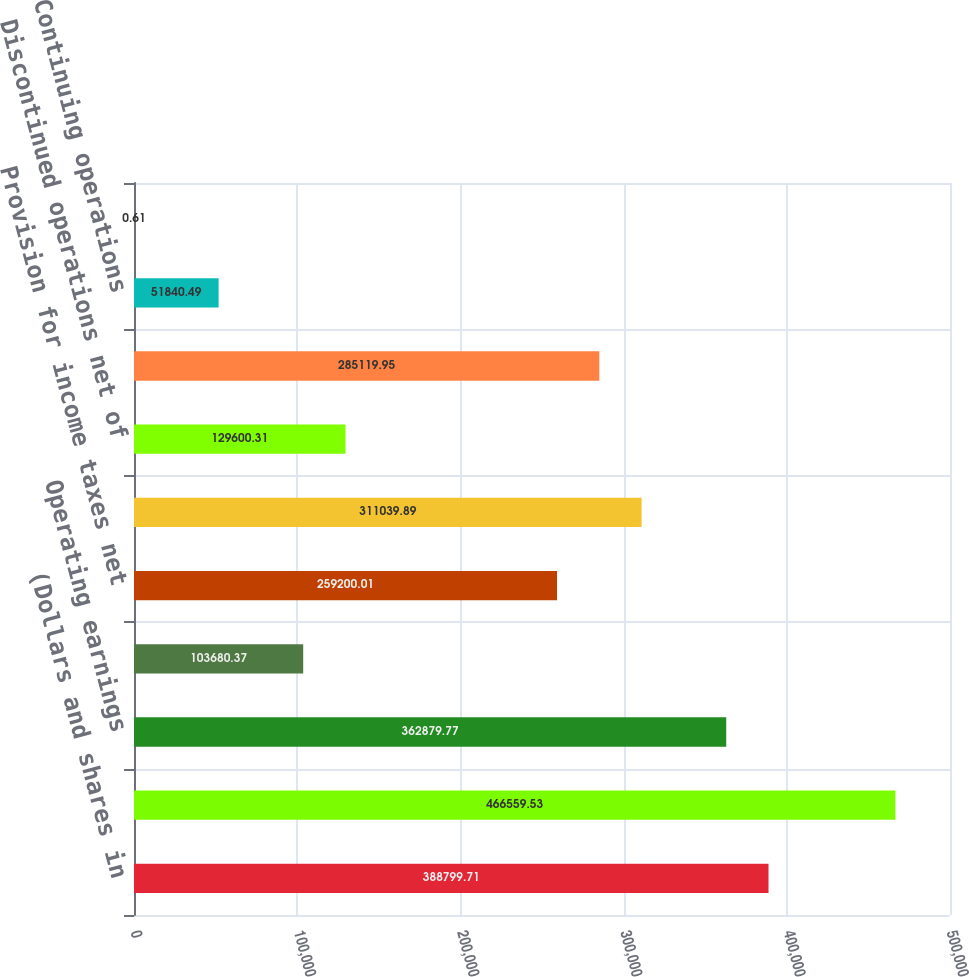Convert chart to OTSL. <chart><loc_0><loc_0><loc_500><loc_500><bar_chart><fcel>(Dollars and shares in<fcel>Net sales<fcel>Operating earnings<fcel>Interest expense net<fcel>Provision for income taxes net<fcel>Earnings from continuing<fcel>Discontinued operations net of<fcel>Net earnings<fcel>Continuing operations<fcel>Discontinued operations<nl><fcel>388800<fcel>466560<fcel>362880<fcel>103680<fcel>259200<fcel>311040<fcel>129600<fcel>285120<fcel>51840.5<fcel>0.61<nl></chart> 